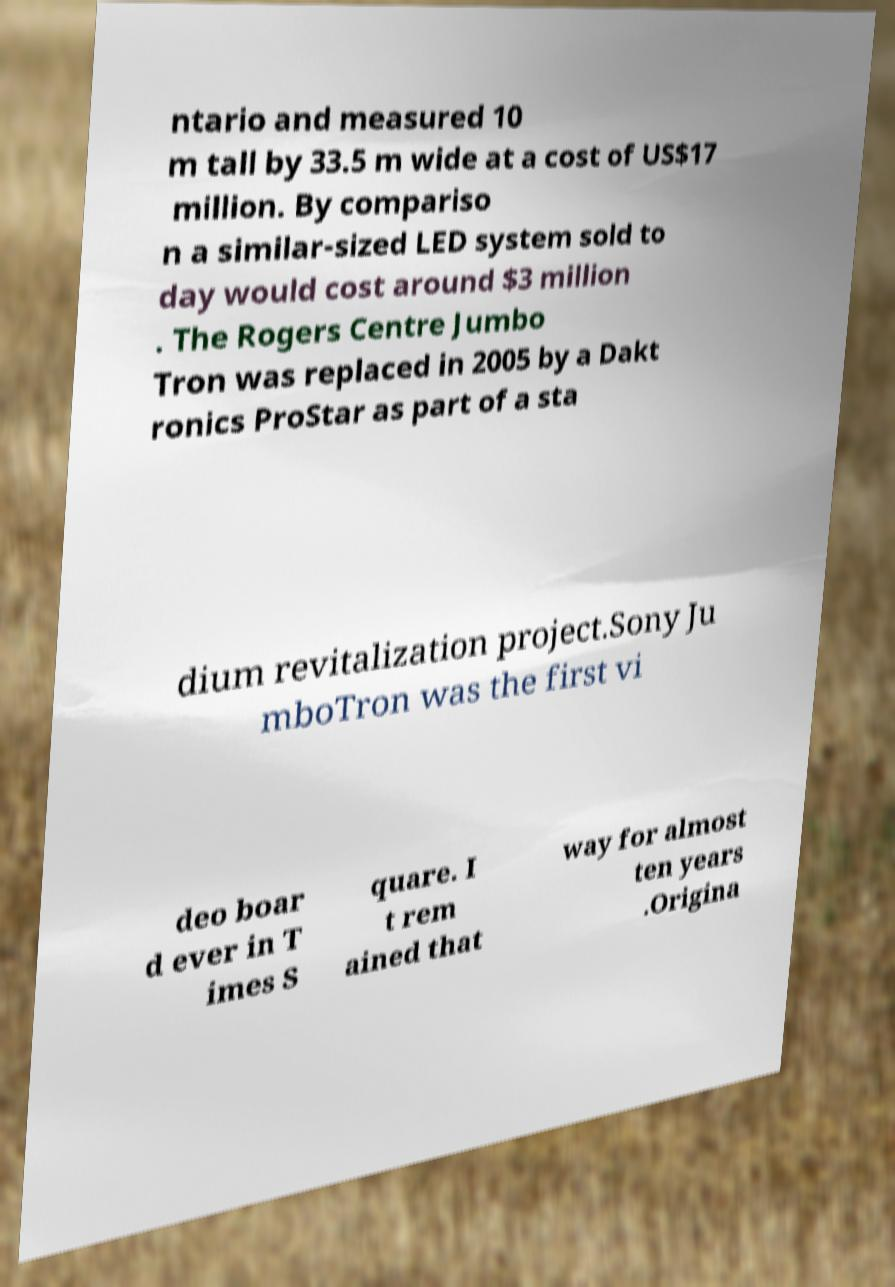There's text embedded in this image that I need extracted. Can you transcribe it verbatim? ntario and measured 10 m tall by 33.5 m wide at a cost of US$17 million. By compariso n a similar-sized LED system sold to day would cost around $3 million . The Rogers Centre Jumbo Tron was replaced in 2005 by a Dakt ronics ProStar as part of a sta dium revitalization project.Sony Ju mboTron was the first vi deo boar d ever in T imes S quare. I t rem ained that way for almost ten years .Origina 